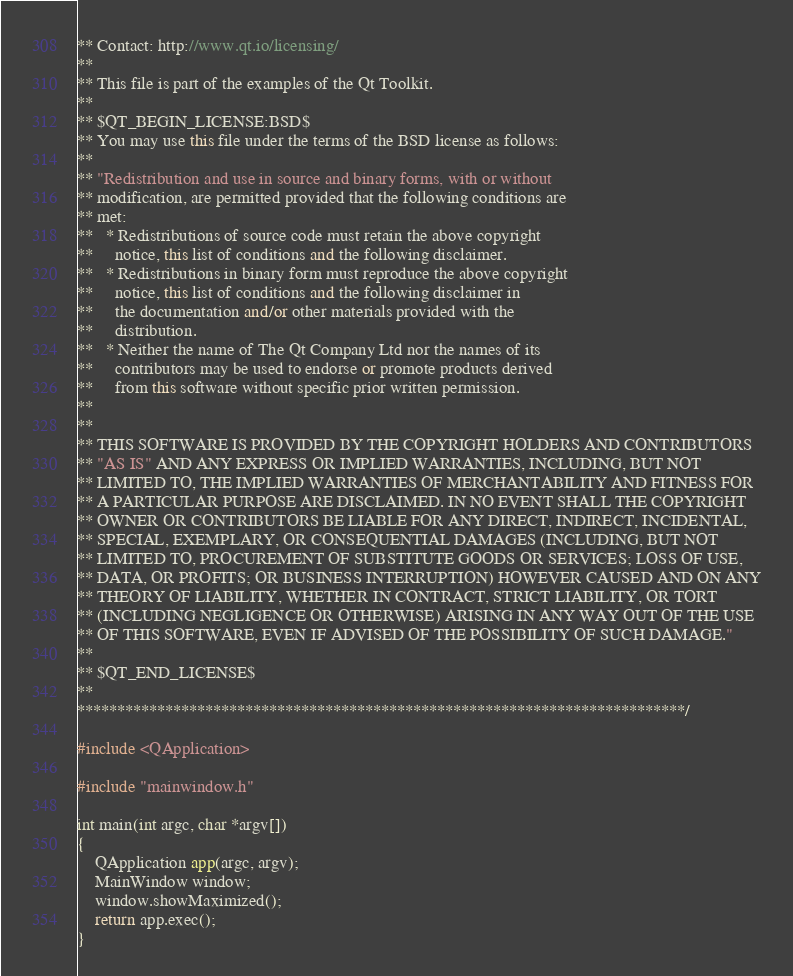Convert code to text. <code><loc_0><loc_0><loc_500><loc_500><_C++_>** Contact: http://www.qt.io/licensing/
**
** This file is part of the examples of the Qt Toolkit.
**
** $QT_BEGIN_LICENSE:BSD$
** You may use this file under the terms of the BSD license as follows:
**
** "Redistribution and use in source and binary forms, with or without
** modification, are permitted provided that the following conditions are
** met:
**   * Redistributions of source code must retain the above copyright
**     notice, this list of conditions and the following disclaimer.
**   * Redistributions in binary form must reproduce the above copyright
**     notice, this list of conditions and the following disclaimer in
**     the documentation and/or other materials provided with the
**     distribution.
**   * Neither the name of The Qt Company Ltd nor the names of its
**     contributors may be used to endorse or promote products derived
**     from this software without specific prior written permission.
**
**
** THIS SOFTWARE IS PROVIDED BY THE COPYRIGHT HOLDERS AND CONTRIBUTORS
** "AS IS" AND ANY EXPRESS OR IMPLIED WARRANTIES, INCLUDING, BUT NOT
** LIMITED TO, THE IMPLIED WARRANTIES OF MERCHANTABILITY AND FITNESS FOR
** A PARTICULAR PURPOSE ARE DISCLAIMED. IN NO EVENT SHALL THE COPYRIGHT
** OWNER OR CONTRIBUTORS BE LIABLE FOR ANY DIRECT, INDIRECT, INCIDENTAL,
** SPECIAL, EXEMPLARY, OR CONSEQUENTIAL DAMAGES (INCLUDING, BUT NOT
** LIMITED TO, PROCUREMENT OF SUBSTITUTE GOODS OR SERVICES; LOSS OF USE,
** DATA, OR PROFITS; OR BUSINESS INTERRUPTION) HOWEVER CAUSED AND ON ANY
** THEORY OF LIABILITY, WHETHER IN CONTRACT, STRICT LIABILITY, OR TORT
** (INCLUDING NEGLIGENCE OR OTHERWISE) ARISING IN ANY WAY OUT OF THE USE
** OF THIS SOFTWARE, EVEN IF ADVISED OF THE POSSIBILITY OF SUCH DAMAGE."
**
** $QT_END_LICENSE$
**
****************************************************************************/

#include <QApplication>

#include "mainwindow.h"

int main(int argc, char *argv[])
{
    QApplication app(argc, argv);
    MainWindow window;
    window.showMaximized();
    return app.exec();
}
</code> 